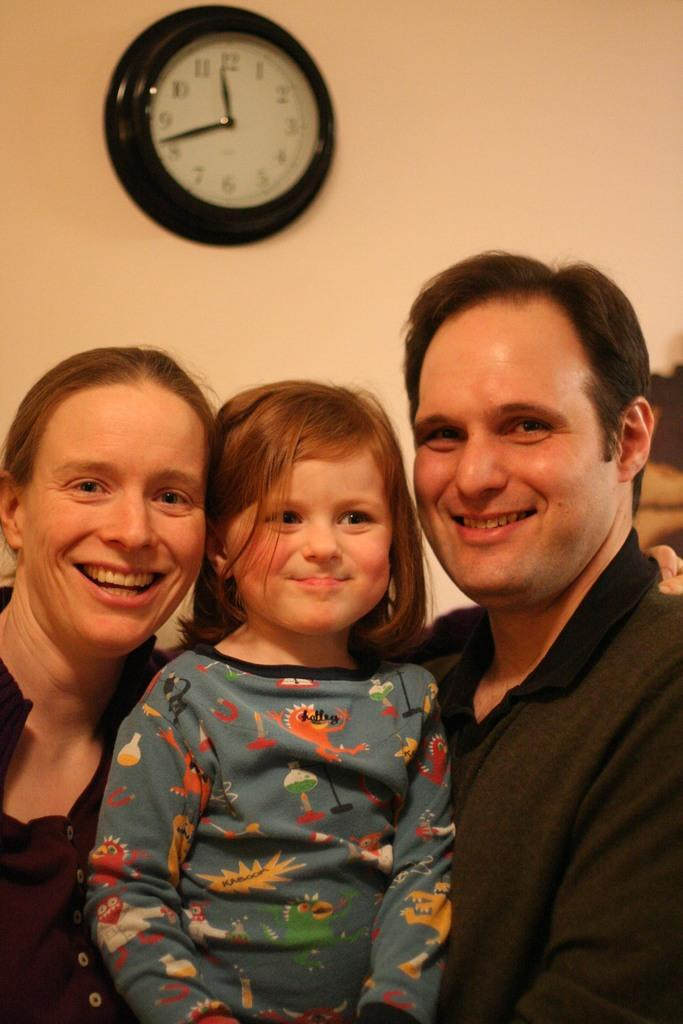<image>
Share a concise interpretation of the image provided. Two adults with a child between them, wearing a shirt with a shirt with a graphic of KABOOM on a jagged yellow shape on it. 